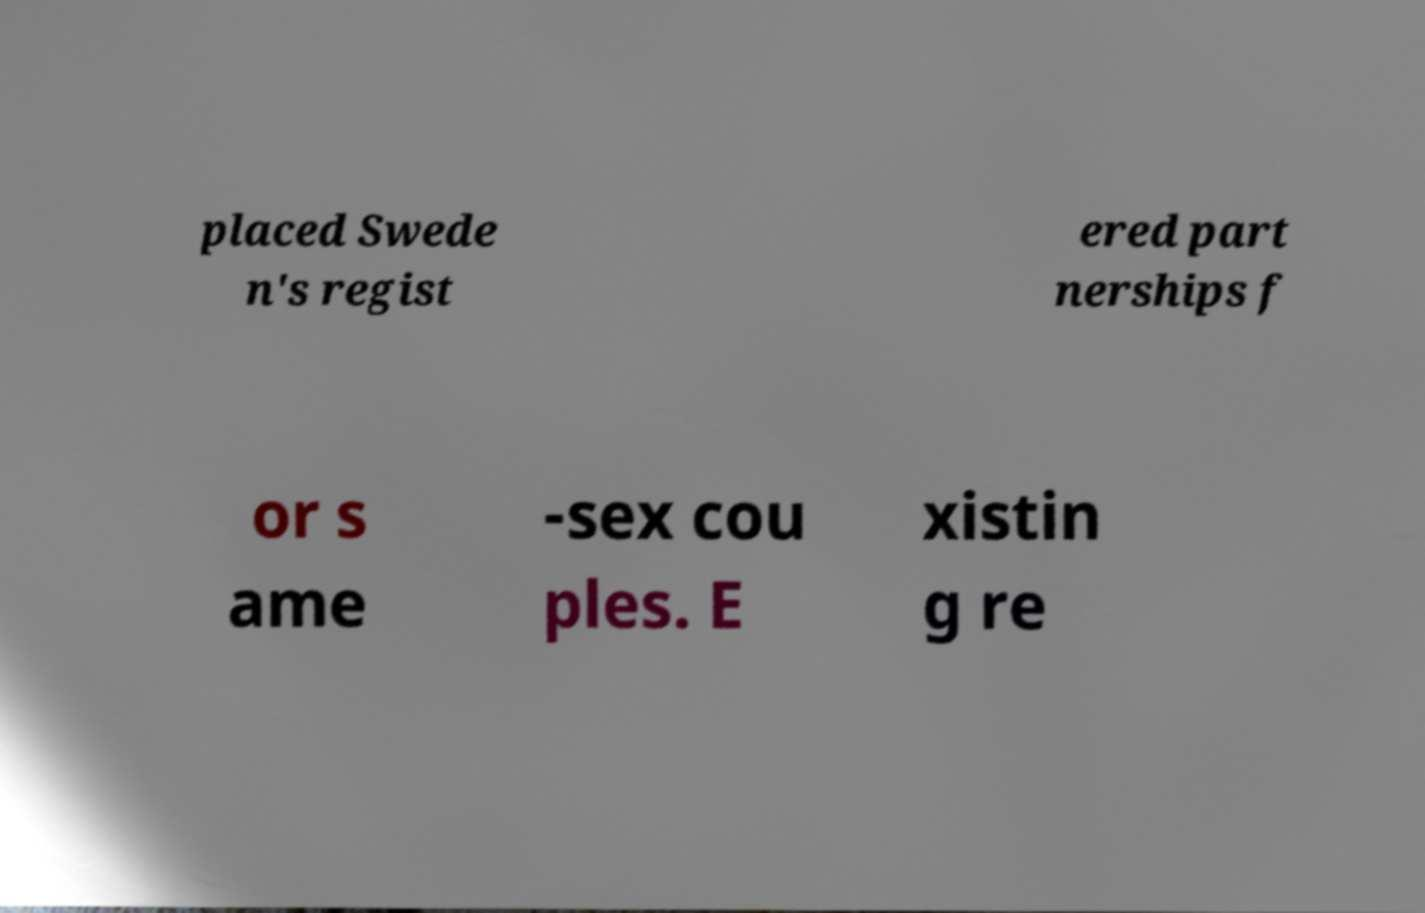What messages or text are displayed in this image? I need them in a readable, typed format. placed Swede n's regist ered part nerships f or s ame -sex cou ples. E xistin g re 